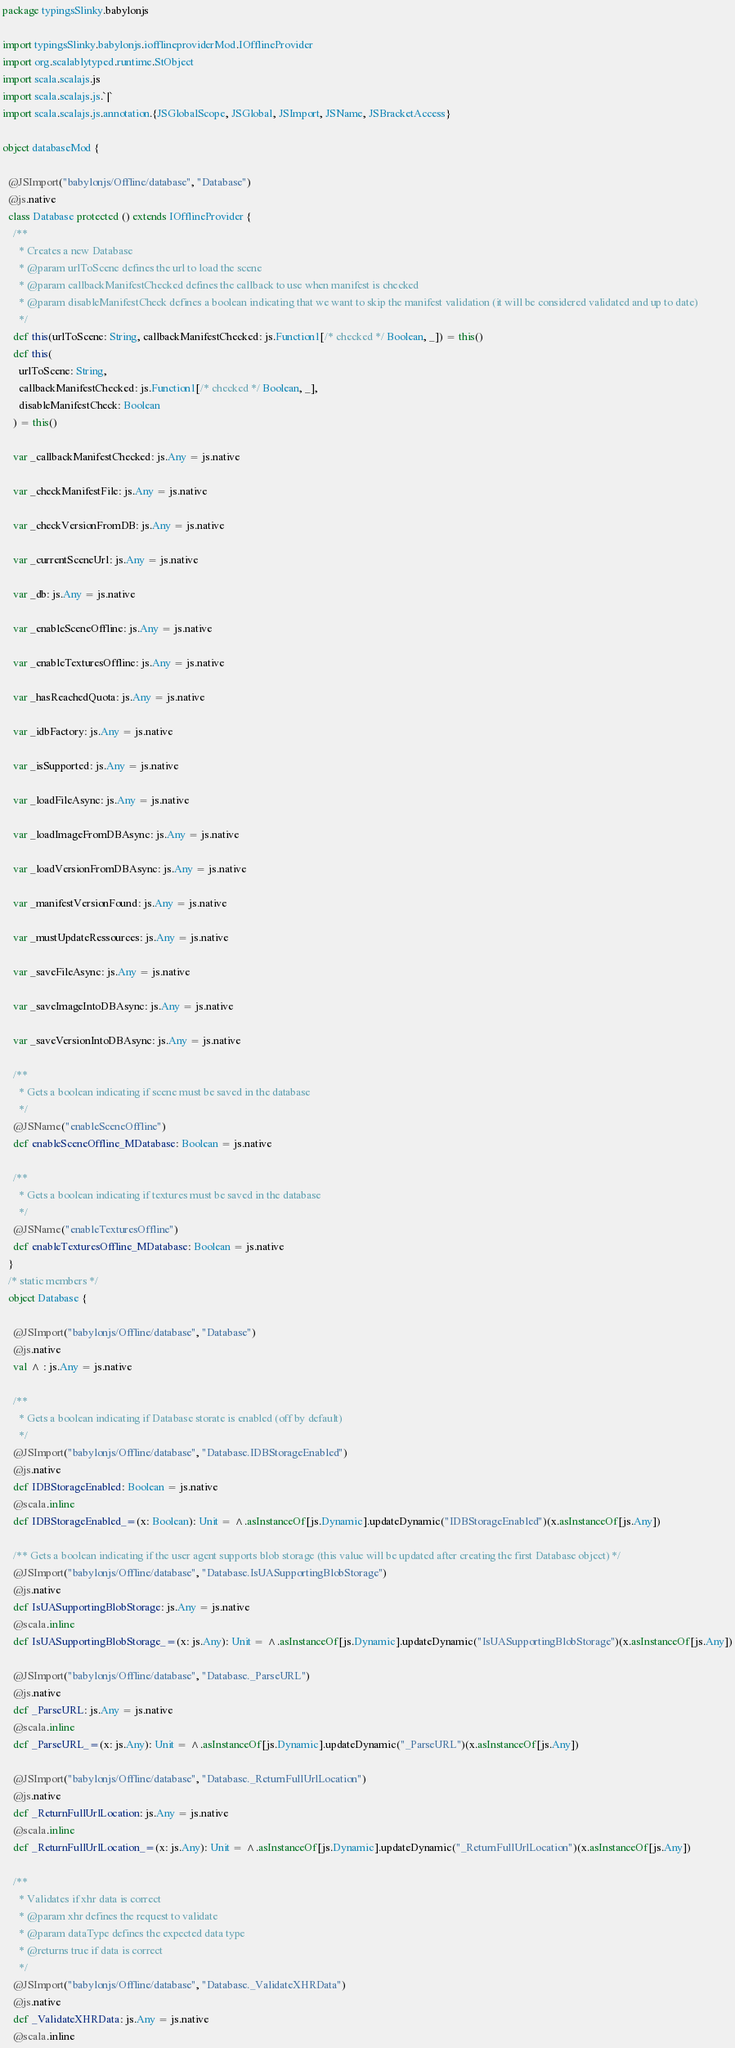Convert code to text. <code><loc_0><loc_0><loc_500><loc_500><_Scala_>package typingsSlinky.babylonjs

import typingsSlinky.babylonjs.iofflineproviderMod.IOfflineProvider
import org.scalablytyped.runtime.StObject
import scala.scalajs.js
import scala.scalajs.js.`|`
import scala.scalajs.js.annotation.{JSGlobalScope, JSGlobal, JSImport, JSName, JSBracketAccess}

object databaseMod {
  
  @JSImport("babylonjs/Offline/database", "Database")
  @js.native
  class Database protected () extends IOfflineProvider {
    /**
      * Creates a new Database
      * @param urlToScene defines the url to load the scene
      * @param callbackManifestChecked defines the callback to use when manifest is checked
      * @param disableManifestCheck defines a boolean indicating that we want to skip the manifest validation (it will be considered validated and up to date)
      */
    def this(urlToScene: String, callbackManifestChecked: js.Function1[/* checked */ Boolean, _]) = this()
    def this(
      urlToScene: String,
      callbackManifestChecked: js.Function1[/* checked */ Boolean, _],
      disableManifestCheck: Boolean
    ) = this()
    
    var _callbackManifestChecked: js.Any = js.native
    
    var _checkManifestFile: js.Any = js.native
    
    var _checkVersionFromDB: js.Any = js.native
    
    var _currentSceneUrl: js.Any = js.native
    
    var _db: js.Any = js.native
    
    var _enableSceneOffline: js.Any = js.native
    
    var _enableTexturesOffline: js.Any = js.native
    
    var _hasReachedQuota: js.Any = js.native
    
    var _idbFactory: js.Any = js.native
    
    var _isSupported: js.Any = js.native
    
    var _loadFileAsync: js.Any = js.native
    
    var _loadImageFromDBAsync: js.Any = js.native
    
    var _loadVersionFromDBAsync: js.Any = js.native
    
    var _manifestVersionFound: js.Any = js.native
    
    var _mustUpdateRessources: js.Any = js.native
    
    var _saveFileAsync: js.Any = js.native
    
    var _saveImageIntoDBAsync: js.Any = js.native
    
    var _saveVersionIntoDBAsync: js.Any = js.native
    
    /**
      * Gets a boolean indicating if scene must be saved in the database
      */
    @JSName("enableSceneOffline")
    def enableSceneOffline_MDatabase: Boolean = js.native
    
    /**
      * Gets a boolean indicating if textures must be saved in the database
      */
    @JSName("enableTexturesOffline")
    def enableTexturesOffline_MDatabase: Boolean = js.native
  }
  /* static members */
  object Database {
    
    @JSImport("babylonjs/Offline/database", "Database")
    @js.native
    val ^ : js.Any = js.native
    
    /**
      * Gets a boolean indicating if Database storate is enabled (off by default)
      */
    @JSImport("babylonjs/Offline/database", "Database.IDBStorageEnabled")
    @js.native
    def IDBStorageEnabled: Boolean = js.native
    @scala.inline
    def IDBStorageEnabled_=(x: Boolean): Unit = ^.asInstanceOf[js.Dynamic].updateDynamic("IDBStorageEnabled")(x.asInstanceOf[js.Any])
    
    /** Gets a boolean indicating if the user agent supports blob storage (this value will be updated after creating the first Database object) */
    @JSImport("babylonjs/Offline/database", "Database.IsUASupportingBlobStorage")
    @js.native
    def IsUASupportingBlobStorage: js.Any = js.native
    @scala.inline
    def IsUASupportingBlobStorage_=(x: js.Any): Unit = ^.asInstanceOf[js.Dynamic].updateDynamic("IsUASupportingBlobStorage")(x.asInstanceOf[js.Any])
    
    @JSImport("babylonjs/Offline/database", "Database._ParseURL")
    @js.native
    def _ParseURL: js.Any = js.native
    @scala.inline
    def _ParseURL_=(x: js.Any): Unit = ^.asInstanceOf[js.Dynamic].updateDynamic("_ParseURL")(x.asInstanceOf[js.Any])
    
    @JSImport("babylonjs/Offline/database", "Database._ReturnFullUrlLocation")
    @js.native
    def _ReturnFullUrlLocation: js.Any = js.native
    @scala.inline
    def _ReturnFullUrlLocation_=(x: js.Any): Unit = ^.asInstanceOf[js.Dynamic].updateDynamic("_ReturnFullUrlLocation")(x.asInstanceOf[js.Any])
    
    /**
      * Validates if xhr data is correct
      * @param xhr defines the request to validate
      * @param dataType defines the expected data type
      * @returns true if data is correct
      */
    @JSImport("babylonjs/Offline/database", "Database._ValidateXHRData")
    @js.native
    def _ValidateXHRData: js.Any = js.native
    @scala.inline</code> 